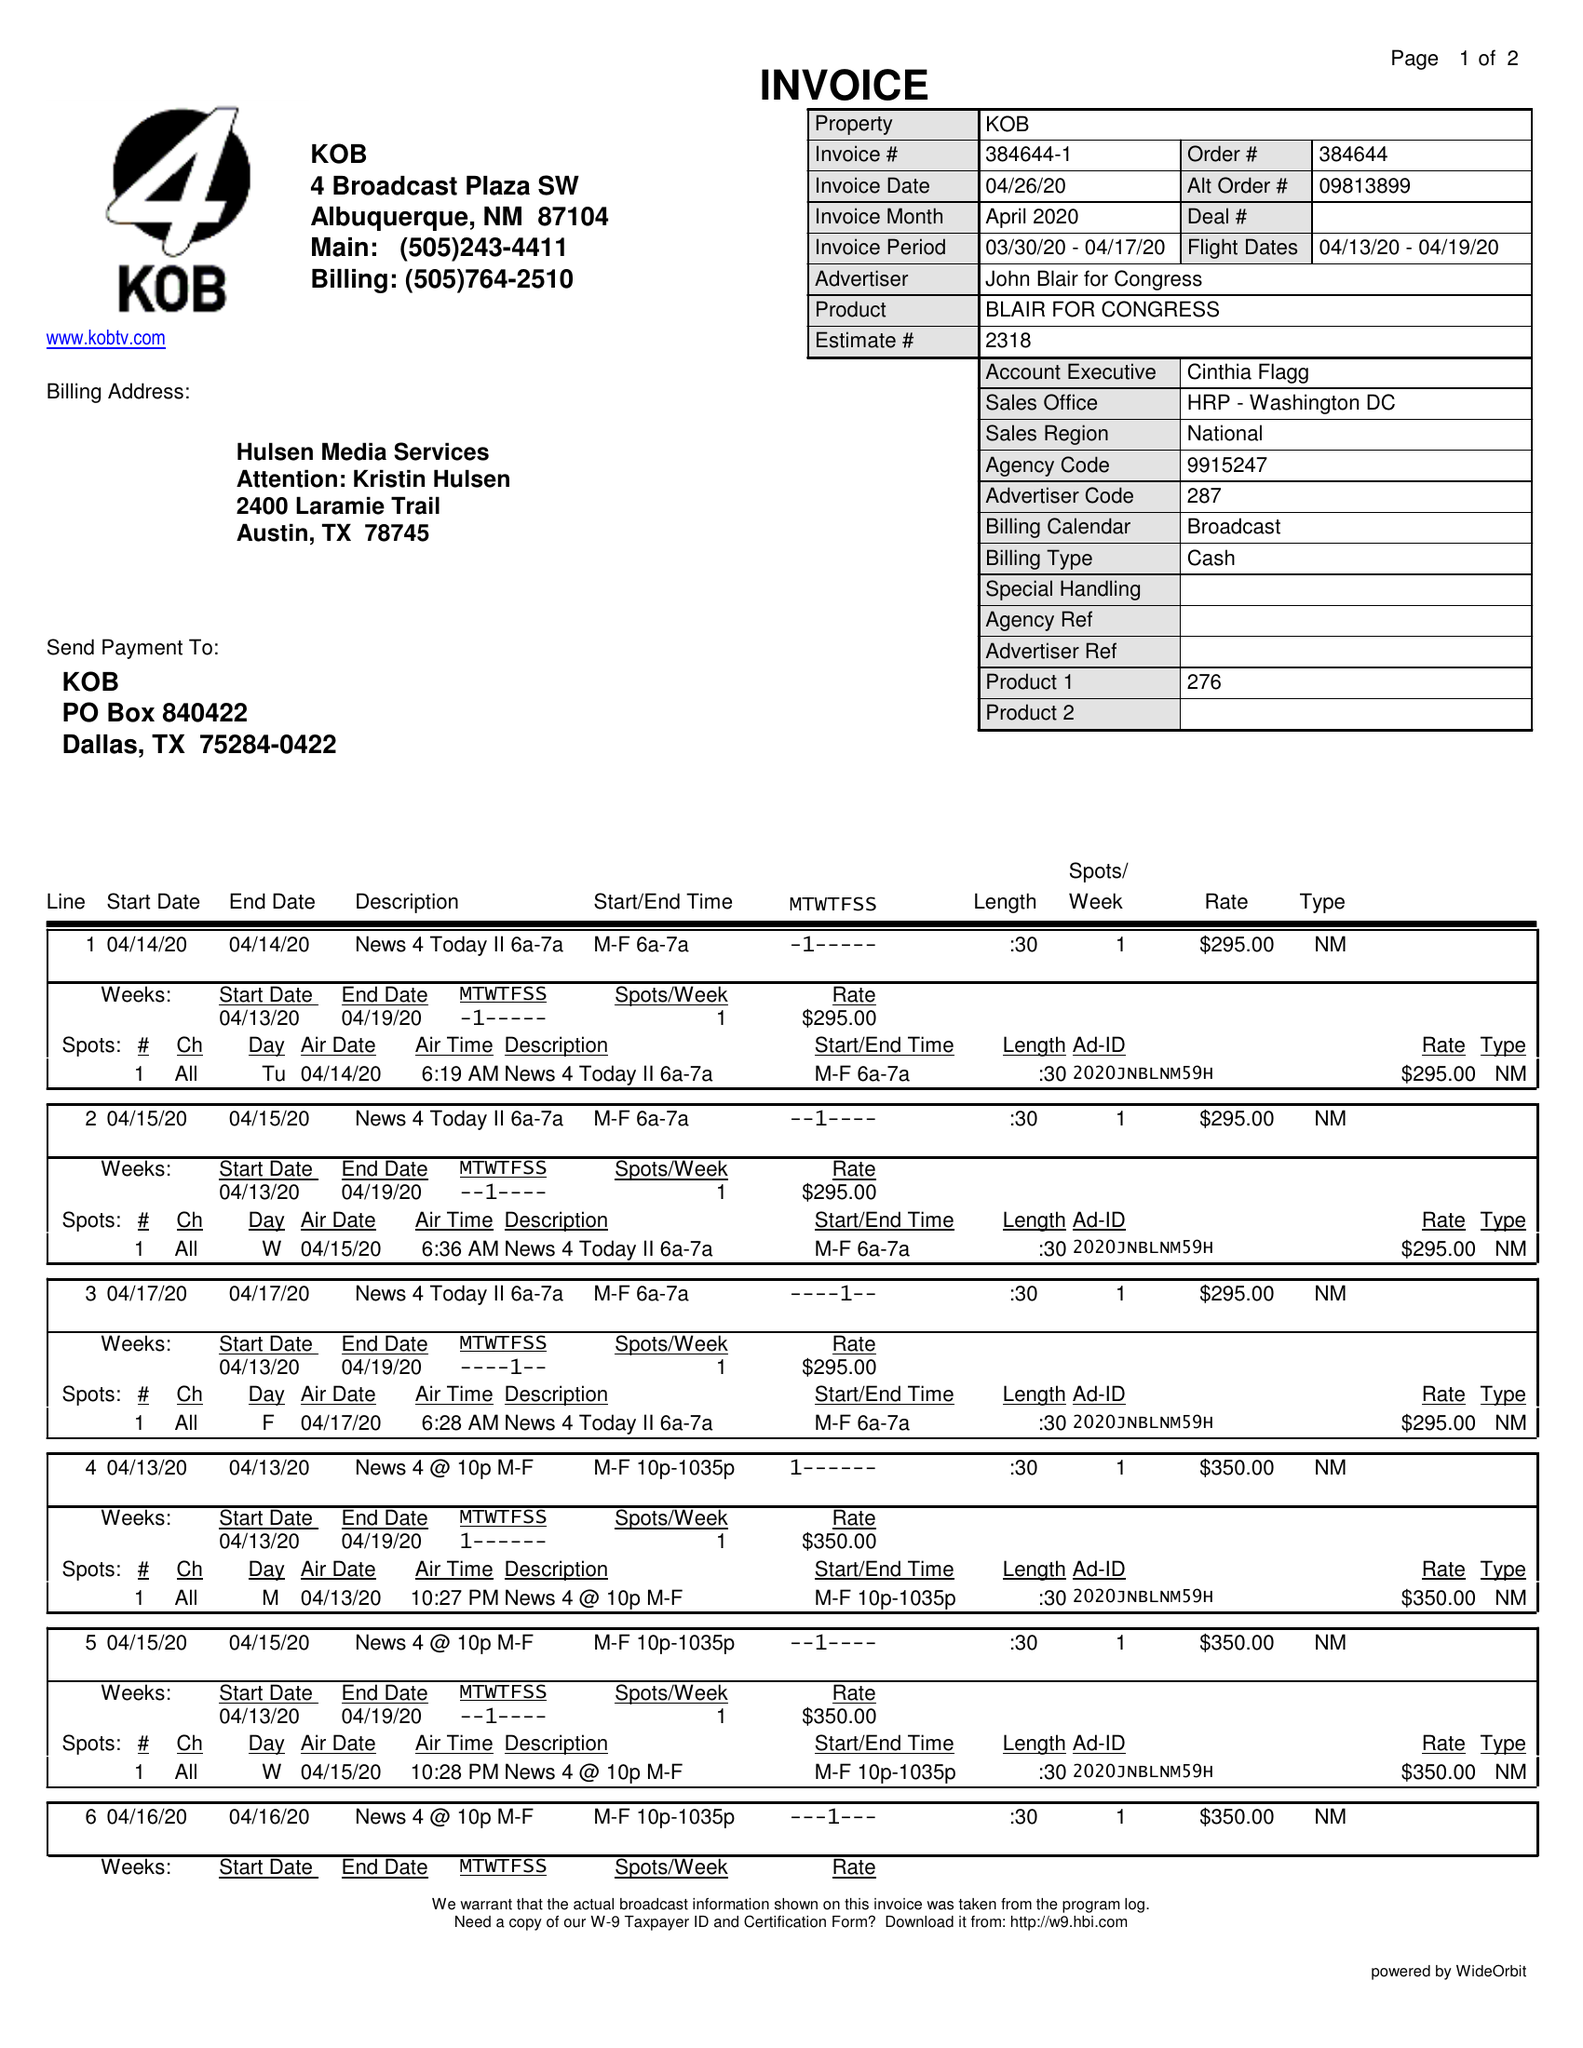What is the value for the contract_num?
Answer the question using a single word or phrase. 384644 